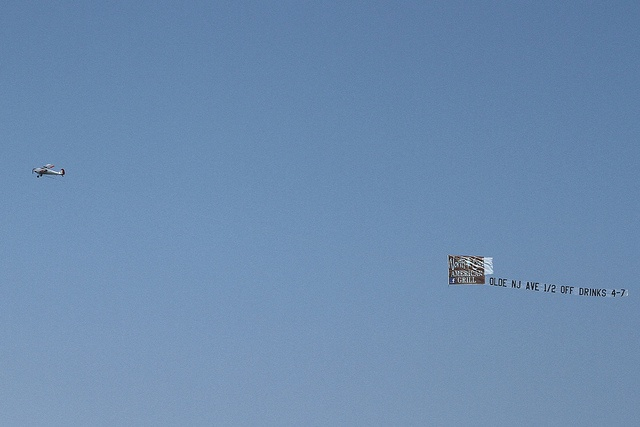Describe the objects in this image and their specific colors. I can see kite in gray, darkgray, black, and lightgray tones and airplane in gray, darkgray, and black tones in this image. 